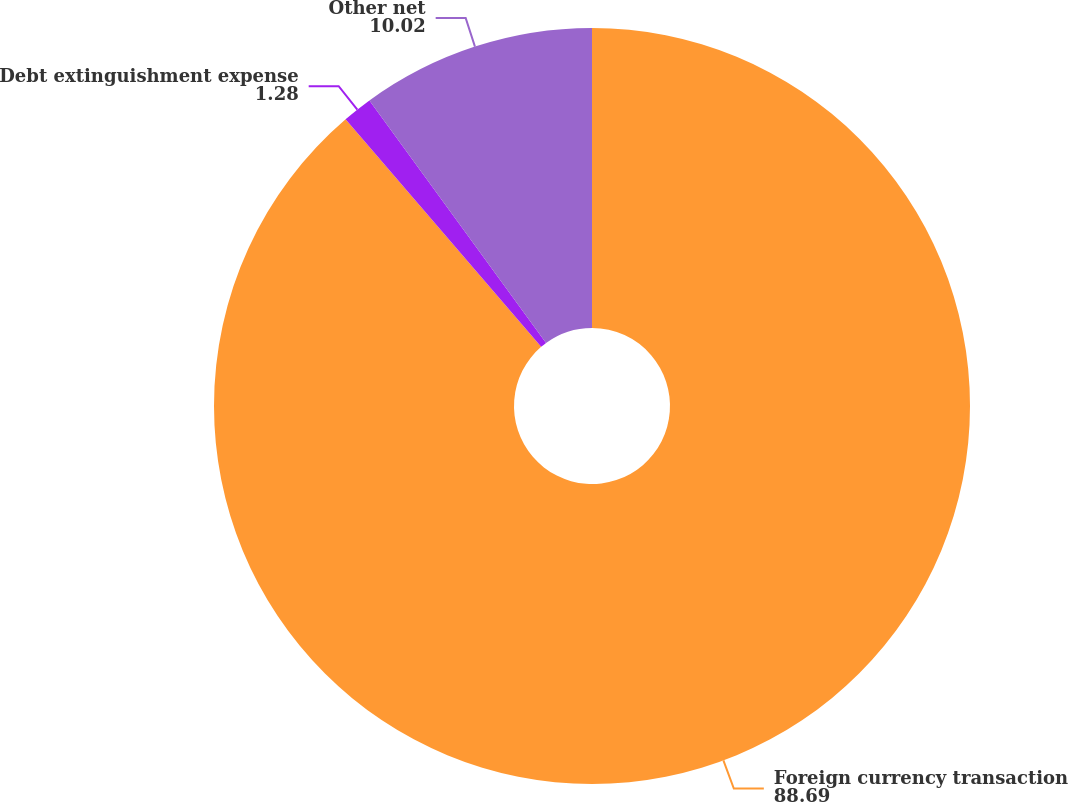<chart> <loc_0><loc_0><loc_500><loc_500><pie_chart><fcel>Foreign currency transaction<fcel>Debt extinguishment expense<fcel>Other net<nl><fcel>88.69%<fcel>1.28%<fcel>10.02%<nl></chart> 